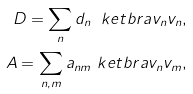<formula> <loc_0><loc_0><loc_500><loc_500>D = \sum _ { n } d _ { n } \ k e t b r a { v _ { n } } { v _ { n } } , \\ A = \sum _ { n , m } a _ { n m } \ k e t b r a { v _ { n } } { v _ { m } } ,</formula> 